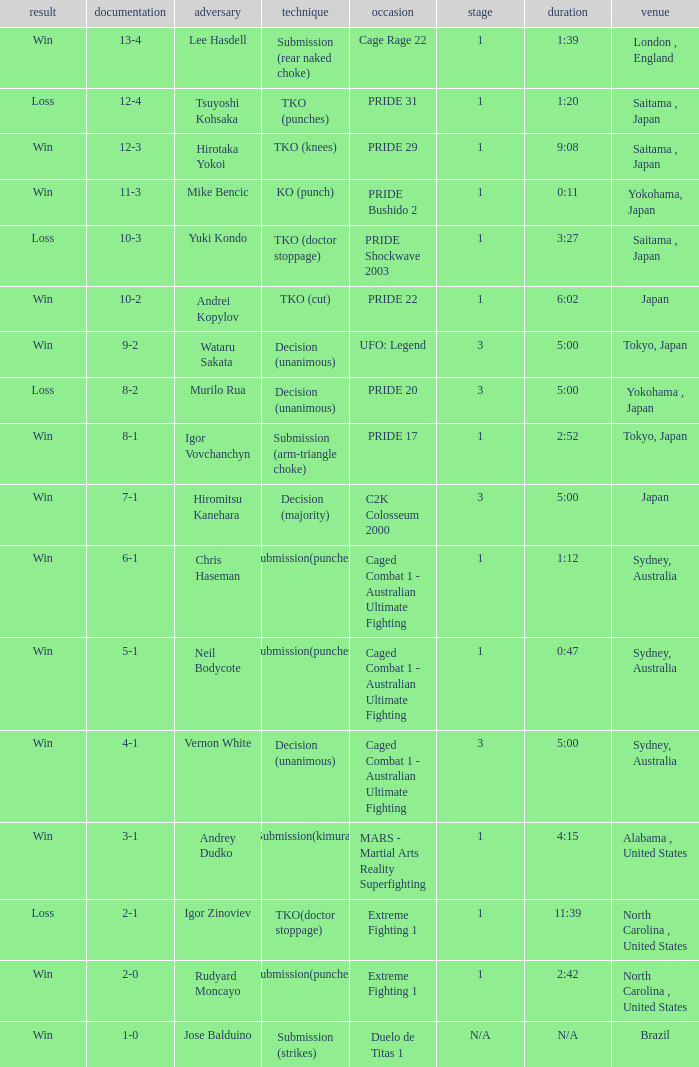Which Record has the Res of win with the Event of extreme fighting 1? 2-0. 